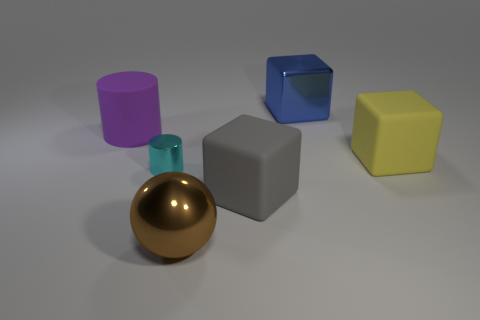Add 2 purple matte balls. How many objects exist? 8 Subtract all cylinders. How many objects are left? 4 Subtract 0 red spheres. How many objects are left? 6 Subtract all blue rubber balls. Subtract all big gray matte blocks. How many objects are left? 5 Add 2 purple rubber cylinders. How many purple rubber cylinders are left? 3 Add 3 blue metal objects. How many blue metal objects exist? 4 